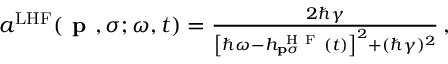Convert formula to latex. <formula><loc_0><loc_0><loc_500><loc_500>\begin{array} { r } { a ^ { L H F } ( p , \sigma ; \omega , t ) = \frac { 2 \hbar { \gamma } } { \left [ \hbar { \omega } - h _ { p \sigma } ^ { H F } ( t ) \right ] ^ { 2 } + ( \hbar { \gamma } ) ^ { 2 } } \, , } \end{array}</formula> 